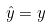<formula> <loc_0><loc_0><loc_500><loc_500>\hat { y } = y</formula> 